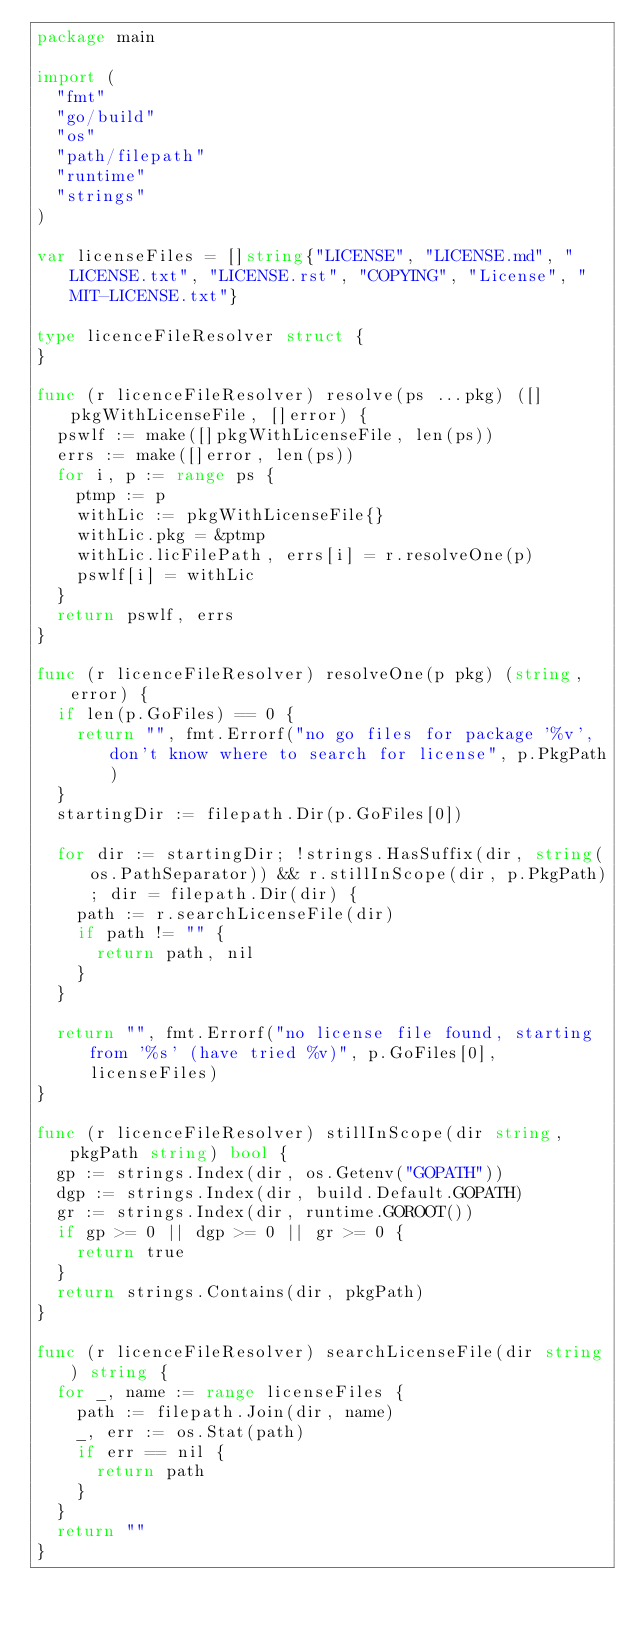Convert code to text. <code><loc_0><loc_0><loc_500><loc_500><_Go_>package main

import (
	"fmt"
	"go/build"
	"os"
	"path/filepath"
	"runtime"
	"strings"
)

var licenseFiles = []string{"LICENSE", "LICENSE.md", "LICENSE.txt", "LICENSE.rst", "COPYING", "License", "MIT-LICENSE.txt"}

type licenceFileResolver struct {
}

func (r licenceFileResolver) resolve(ps ...pkg) ([]pkgWithLicenseFile, []error) {
	pswlf := make([]pkgWithLicenseFile, len(ps))
	errs := make([]error, len(ps))
	for i, p := range ps {
		ptmp := p
		withLic := pkgWithLicenseFile{}
		withLic.pkg = &ptmp
		withLic.licFilePath, errs[i] = r.resolveOne(p)
		pswlf[i] = withLic
	}
	return pswlf, errs
}

func (r licenceFileResolver) resolveOne(p pkg) (string, error) {
	if len(p.GoFiles) == 0 {
		return "", fmt.Errorf("no go files for package '%v', don't know where to search for license", p.PkgPath)
	}
	startingDir := filepath.Dir(p.GoFiles[0])

	for dir := startingDir; !strings.HasSuffix(dir, string(os.PathSeparator)) && r.stillInScope(dir, p.PkgPath); dir = filepath.Dir(dir) {
		path := r.searchLicenseFile(dir)
		if path != "" {
			return path, nil
		}
	}

	return "", fmt.Errorf("no license file found, starting from '%s' (have tried %v)", p.GoFiles[0], licenseFiles)
}

func (r licenceFileResolver) stillInScope(dir string, pkgPath string) bool {
	gp := strings.Index(dir, os.Getenv("GOPATH"))
	dgp := strings.Index(dir, build.Default.GOPATH)
	gr := strings.Index(dir, runtime.GOROOT())
	if gp >= 0 || dgp >= 0 || gr >= 0 {
		return true
	}
	return strings.Contains(dir, pkgPath)
}

func (r licenceFileResolver) searchLicenseFile(dir string) string {
	for _, name := range licenseFiles {
		path := filepath.Join(dir, name)
		_, err := os.Stat(path)
		if err == nil {
			return path
		}
	}
	return ""
}
</code> 